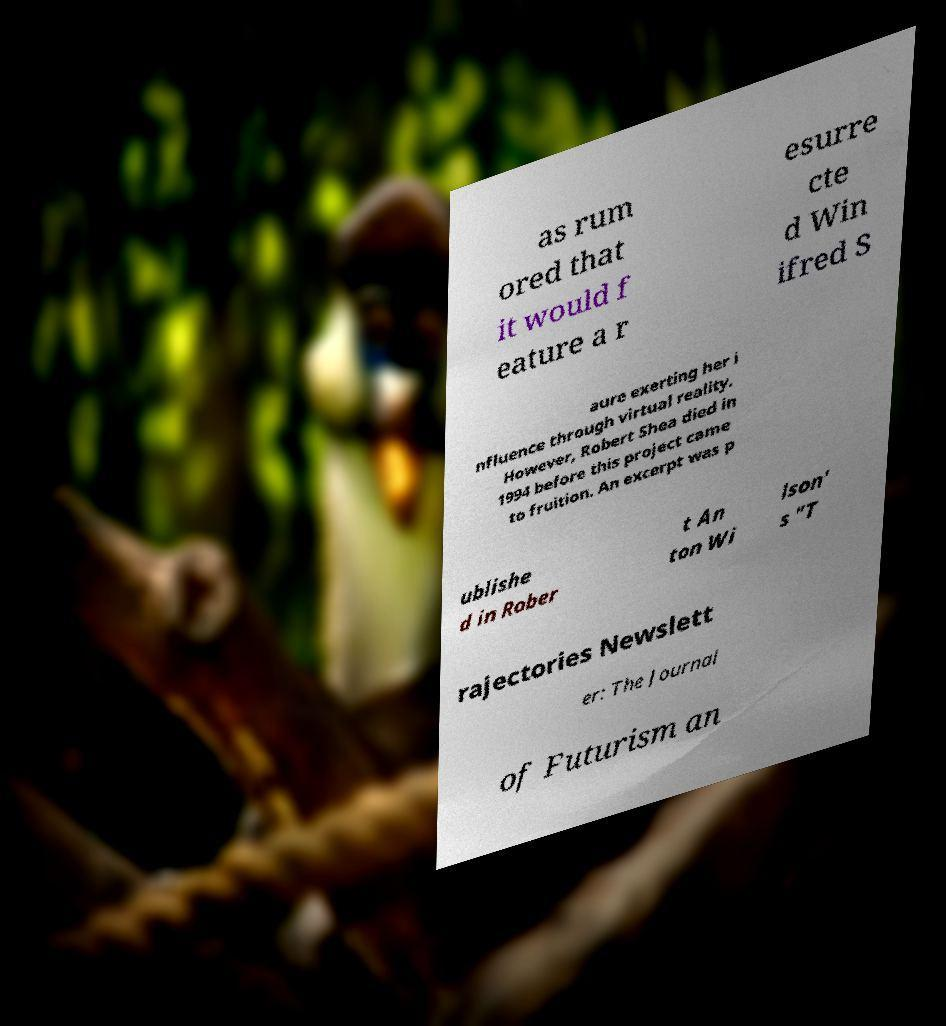Can you read and provide the text displayed in the image?This photo seems to have some interesting text. Can you extract and type it out for me? as rum ored that it would f eature a r esurre cte d Win ifred S aure exerting her i nfluence through virtual reality. However, Robert Shea died in 1994 before this project came to fruition. An excerpt was p ublishe d in Rober t An ton Wi lson' s "T rajectories Newslett er: The Journal of Futurism an 